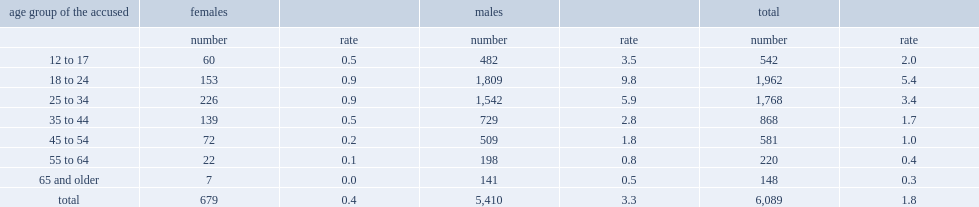Overall, which age group has the highest rate of accused of homicide? 18 to 24. 